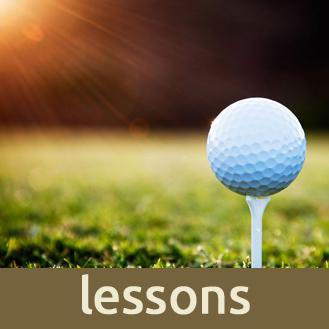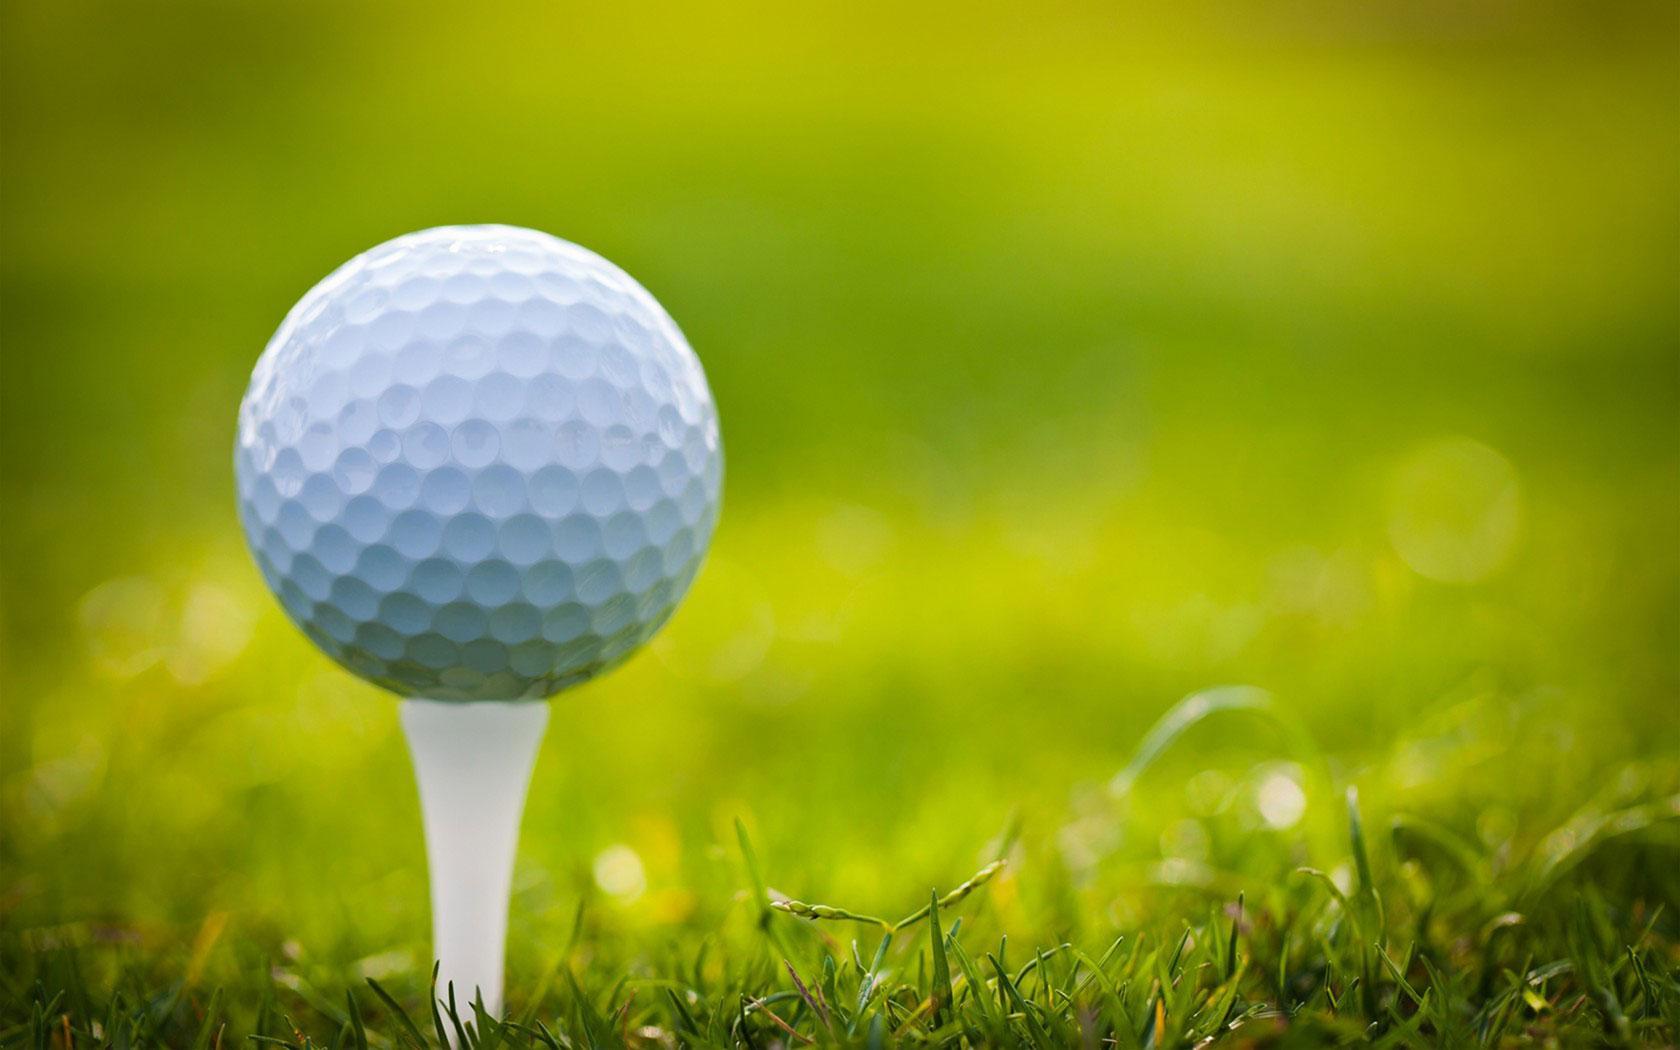The first image is the image on the left, the second image is the image on the right. Assess this claim about the two images: "Golf clubs are near the ball in both images.". Correct or not? Answer yes or no. No. The first image is the image on the left, the second image is the image on the right. Considering the images on both sides, is "Both golf balls have a golf club next to them." valid? Answer yes or no. No. 